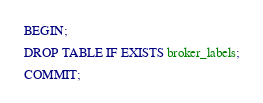Convert code to text. <code><loc_0><loc_0><loc_500><loc_500><_SQL_>BEGIN;

DROP TABLE IF EXISTS broker_labels;

COMMIT;</code> 